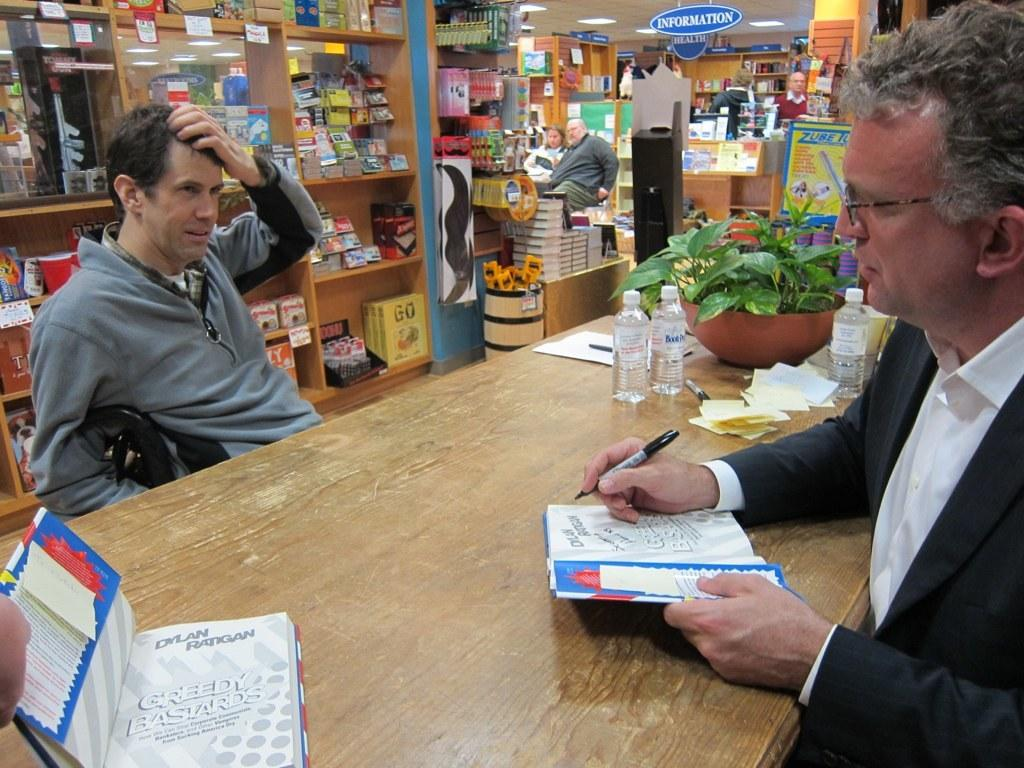<image>
Offer a succinct explanation of the picture presented. A guy signing a book named Dylan Ratigan Greedy. 